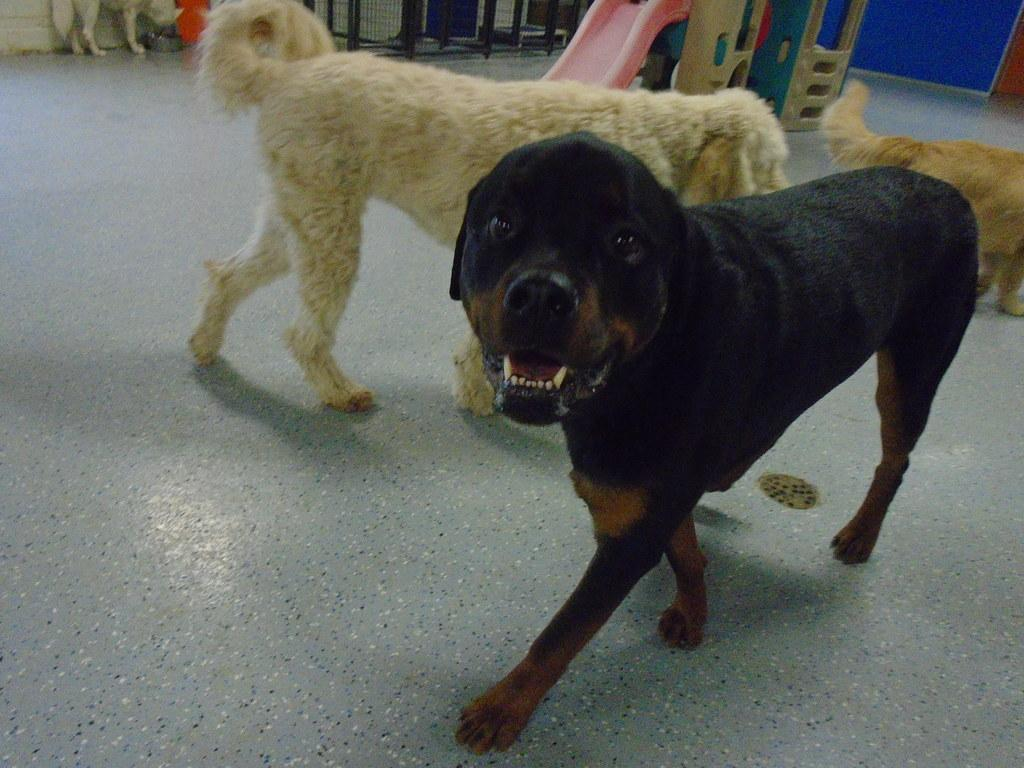What type of animals are present in the image? There are dogs in the image. Where are the dogs located in the image? The dogs are on the floor. What type of shirt is the dog wearing in the image? There are no shirts present in the image, as dogs do not wear clothing. 